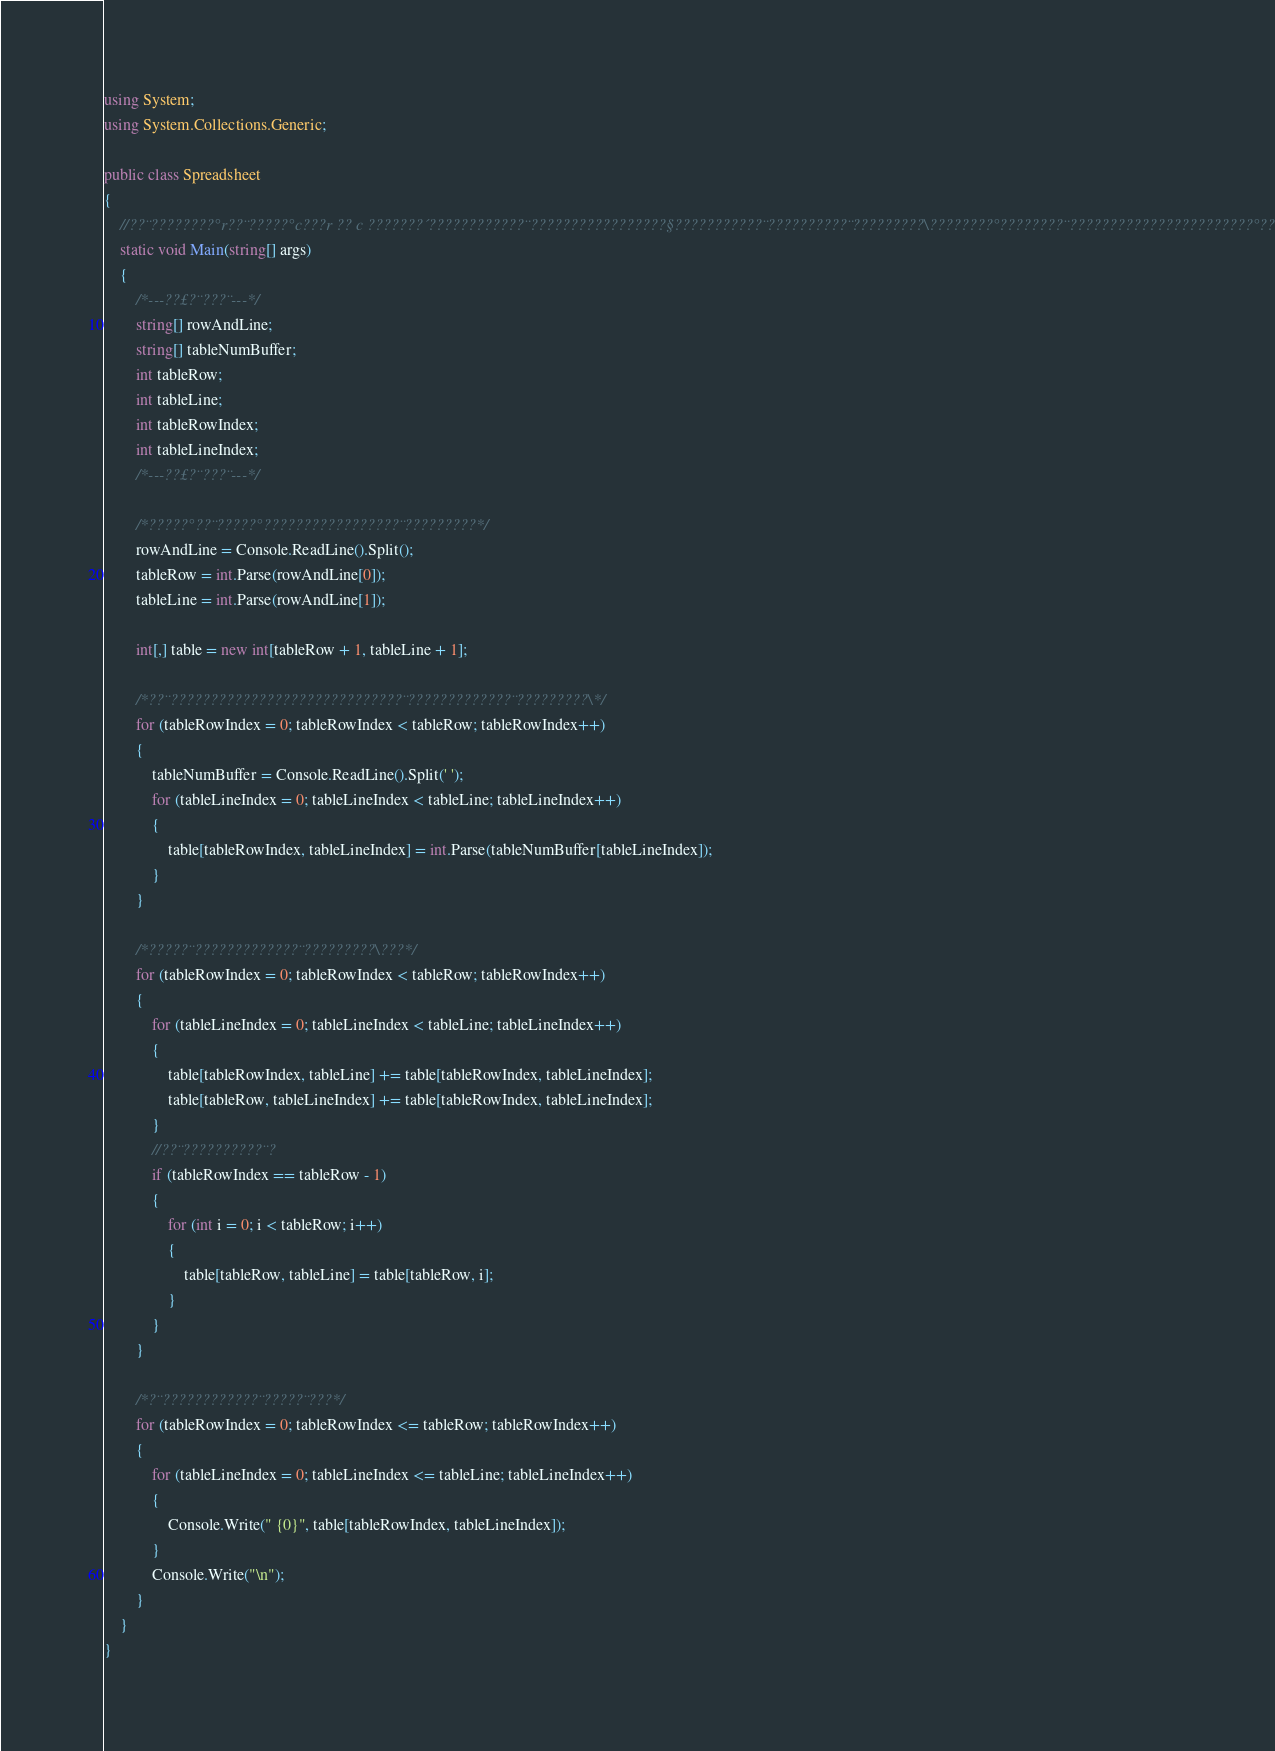Convert code to text. <code><loc_0><loc_0><loc_500><loc_500><_C#_>using System;
using System.Collections.Generic;

public class Spreadsheet
{
    //??¨????????°r??¨?????°c???r ?? c ???????´????????????¨?????????????????§???????????¨??????????¨?????????\????????°????????¨???????????????????????°??????
    static void Main(string[] args)
    {
        /*---??£?¨???¨---*/
        string[] rowAndLine;
        string[] tableNumBuffer;
        int tableRow;
        int tableLine;
        int tableRowIndex;
        int tableLineIndex;
        /*---??£?¨???¨---*/

        /*?????°??¨?????°?????????????????¨?????????*/
        rowAndLine = Console.ReadLine().Split();
        tableRow = int.Parse(rowAndLine[0]);
        tableLine = int.Parse(rowAndLine[1]);

        int[,] table = new int[tableRow + 1, tableLine + 1];

        /*??¨?????????????????????????????¨?????????????¨?????????\*/
        for (tableRowIndex = 0; tableRowIndex < tableRow; tableRowIndex++)
        {
            tableNumBuffer = Console.ReadLine().Split(' ');
            for (tableLineIndex = 0; tableLineIndex < tableLine; tableLineIndex++)
            {
                table[tableRowIndex, tableLineIndex] = int.Parse(tableNumBuffer[tableLineIndex]);
            }
        }

        /*?????¨?????????????¨?????????\???*/
        for (tableRowIndex = 0; tableRowIndex < tableRow; tableRowIndex++)
        {
            for (tableLineIndex = 0; tableLineIndex < tableLine; tableLineIndex++)
            {
                table[tableRowIndex, tableLine] += table[tableRowIndex, tableLineIndex];
                table[tableRow, tableLineIndex] += table[tableRowIndex, tableLineIndex];
            }
            //??¨??????????¨?
            if (tableRowIndex == tableRow - 1)
            {
                for (int i = 0; i < tableRow; i++)
                {
                    table[tableRow, tableLine] = table[tableRow, i];
                }
            }
        }

        /*?¨????????????¨?????¨???*/
        for (tableRowIndex = 0; tableRowIndex <= tableRow; tableRowIndex++)
        {
            for (tableLineIndex = 0; tableLineIndex <= tableLine; tableLineIndex++)
            {
                Console.Write(" {0}", table[tableRowIndex, tableLineIndex]);
            }
            Console.Write("\n");
        }
    }
}</code> 